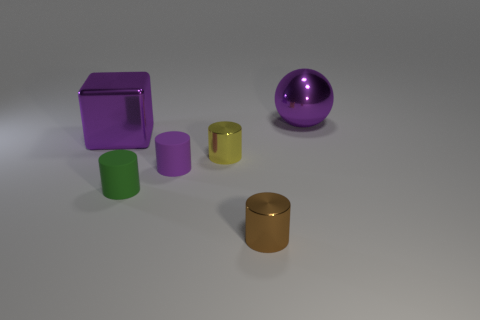There is a cube that is the same color as the large sphere; what is its size?
Your answer should be very brief. Large. The big shiny object that is the same color as the large block is what shape?
Ensure brevity in your answer.  Sphere. What number of things are there?
Offer a very short reply. 6. What shape is the object that is made of the same material as the green cylinder?
Make the answer very short. Cylinder. Is there anything else of the same color as the big block?
Your answer should be compact. Yes. There is a cube; is its color the same as the big shiny thing right of the large purple metallic block?
Provide a succinct answer. Yes. Are there fewer small purple matte cylinders behind the large block than small yellow matte cubes?
Your answer should be very brief. No. What is the large thing that is in front of the big purple ball made of?
Offer a very short reply. Metal. How many other things are there of the same size as the purple cylinder?
Provide a short and direct response. 3. There is a purple block; is its size the same as the metal thing in front of the yellow metallic object?
Provide a short and direct response. No. 